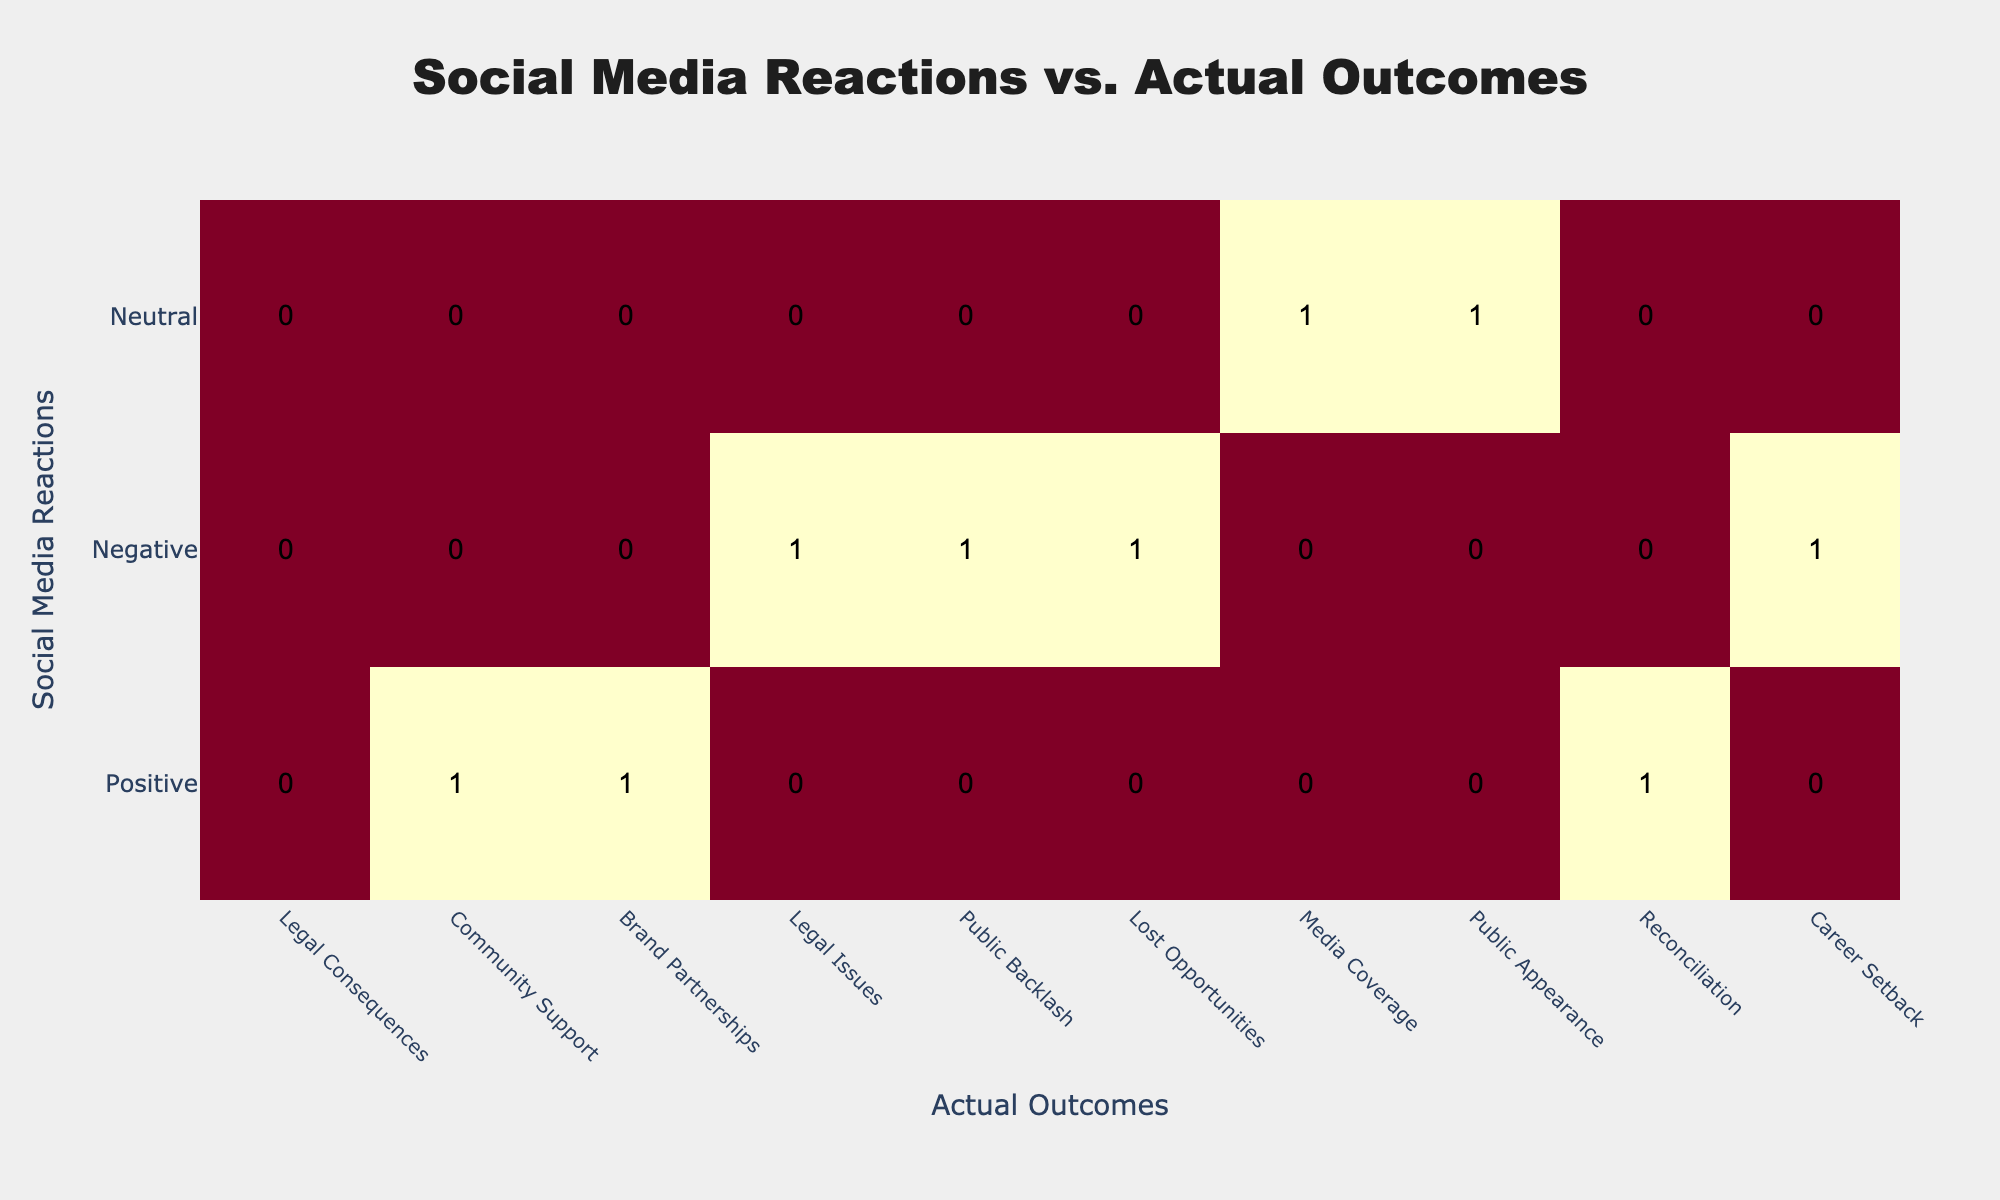What is the total count of positive social media reactions? From the table, we can identify the counts of 'Positive' reactions: 1 for 'Community Support', 1 for 'Brand Partnerships', and 1 for 'Reconciliation'. Adding these together gives a total of 3 positive reactions.
Answer: 3 Which actual outcome is associated with the highest number of negative social media reactions? Looking at the 'Negative' row, we see that 'Public Backlash' and 'Legal Issues' both have 1 count, but 'Lost Opportunities' has 1. To find the highest, we note that all three outcomes are equal with a count of 1. Thus, they collectively hold the highest.
Answer: Public Backlash, Legal Issues, Lost Opportunities Is the count of neutral outcomes greater than the count of positive outcomes? The 'Neutral' row shows 1 for 'Media Coverage' and 1 for 'Public Appearance', making a total of 2 neutral outcomes. The positive outcomes total to 3, so the statement being considered is false.
Answer: No How many total actual outcomes are there for negative social media reactions? The 'Negative' row lists three outcomes: 'Legal Issues', 'Public Backlash', and 'Lost Opportunities', each with a count of 1. Adding these gives us a total of 3 distinct negative outcomes.
Answer: 3 If we consider only the positive outcomes, what is the ratio of reconciliation to the total positive outcomes? The positive outcomes, as noted, total to 3, with 'Reconciliation' being 1 of those. The ratio is 1:3. This means for every positive outcome, one of them is reconciliation.
Answer: 1:3 